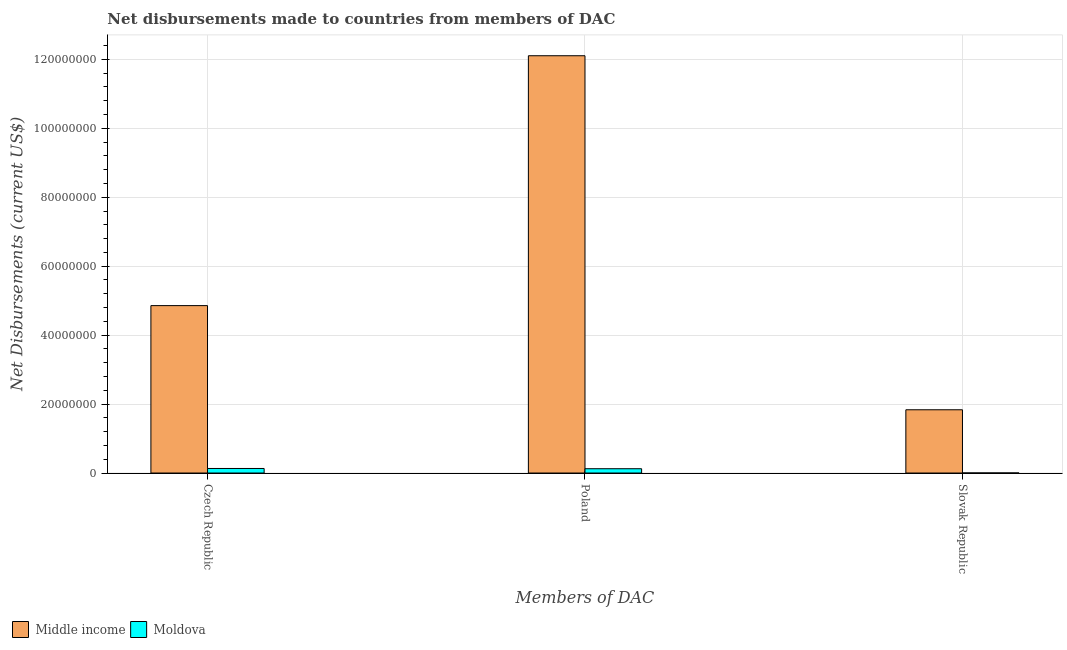How many different coloured bars are there?
Your answer should be compact. 2. How many groups of bars are there?
Your answer should be very brief. 3. Are the number of bars per tick equal to the number of legend labels?
Provide a succinct answer. Yes. Are the number of bars on each tick of the X-axis equal?
Make the answer very short. Yes. How many bars are there on the 1st tick from the left?
Keep it short and to the point. 2. What is the label of the 2nd group of bars from the left?
Offer a very short reply. Poland. What is the net disbursements made by czech republic in Moldova?
Your answer should be very brief. 1.32e+06. Across all countries, what is the maximum net disbursements made by slovak republic?
Your answer should be very brief. 1.84e+07. Across all countries, what is the minimum net disbursements made by poland?
Offer a terse response. 1.25e+06. In which country was the net disbursements made by poland minimum?
Provide a succinct answer. Moldova. What is the total net disbursements made by slovak republic in the graph?
Make the answer very short. 1.84e+07. What is the difference between the net disbursements made by poland in Middle income and that in Moldova?
Provide a short and direct response. 1.20e+08. What is the difference between the net disbursements made by poland in Middle income and the net disbursements made by slovak republic in Moldova?
Your answer should be compact. 1.21e+08. What is the average net disbursements made by poland per country?
Give a very brief answer. 6.11e+07. What is the difference between the net disbursements made by poland and net disbursements made by slovak republic in Moldova?
Keep it short and to the point. 1.23e+06. In how many countries, is the net disbursements made by poland greater than 76000000 US$?
Your response must be concise. 1. What is the ratio of the net disbursements made by poland in Moldova to that in Middle income?
Provide a succinct answer. 0.01. Is the net disbursements made by poland in Moldova less than that in Middle income?
Give a very brief answer. Yes. What is the difference between the highest and the second highest net disbursements made by poland?
Your answer should be very brief. 1.20e+08. What is the difference between the highest and the lowest net disbursements made by poland?
Provide a short and direct response. 1.20e+08. What does the 2nd bar from the left in Czech Republic represents?
Keep it short and to the point. Moldova. How many bars are there?
Keep it short and to the point. 6. What is the difference between two consecutive major ticks on the Y-axis?
Your answer should be compact. 2.00e+07. Are the values on the major ticks of Y-axis written in scientific E-notation?
Your answer should be compact. No. Does the graph contain any zero values?
Offer a terse response. No. Does the graph contain grids?
Your answer should be very brief. Yes. Where does the legend appear in the graph?
Ensure brevity in your answer.  Bottom left. What is the title of the graph?
Your answer should be very brief. Net disbursements made to countries from members of DAC. What is the label or title of the X-axis?
Your response must be concise. Members of DAC. What is the label or title of the Y-axis?
Your response must be concise. Net Disbursements (current US$). What is the Net Disbursements (current US$) in Middle income in Czech Republic?
Give a very brief answer. 4.86e+07. What is the Net Disbursements (current US$) in Moldova in Czech Republic?
Offer a terse response. 1.32e+06. What is the Net Disbursements (current US$) of Middle income in Poland?
Make the answer very short. 1.21e+08. What is the Net Disbursements (current US$) in Moldova in Poland?
Provide a succinct answer. 1.25e+06. What is the Net Disbursements (current US$) of Middle income in Slovak Republic?
Make the answer very short. 1.84e+07. What is the Net Disbursements (current US$) of Moldova in Slovak Republic?
Provide a short and direct response. 2.00e+04. Across all Members of DAC, what is the maximum Net Disbursements (current US$) of Middle income?
Give a very brief answer. 1.21e+08. Across all Members of DAC, what is the maximum Net Disbursements (current US$) in Moldova?
Ensure brevity in your answer.  1.32e+06. Across all Members of DAC, what is the minimum Net Disbursements (current US$) in Middle income?
Offer a very short reply. 1.84e+07. Across all Members of DAC, what is the minimum Net Disbursements (current US$) in Moldova?
Provide a short and direct response. 2.00e+04. What is the total Net Disbursements (current US$) in Middle income in the graph?
Provide a short and direct response. 1.88e+08. What is the total Net Disbursements (current US$) of Moldova in the graph?
Your answer should be compact. 2.59e+06. What is the difference between the Net Disbursements (current US$) in Middle income in Czech Republic and that in Poland?
Ensure brevity in your answer.  -7.25e+07. What is the difference between the Net Disbursements (current US$) of Moldova in Czech Republic and that in Poland?
Keep it short and to the point. 7.00e+04. What is the difference between the Net Disbursements (current US$) in Middle income in Czech Republic and that in Slovak Republic?
Ensure brevity in your answer.  3.02e+07. What is the difference between the Net Disbursements (current US$) in Moldova in Czech Republic and that in Slovak Republic?
Your answer should be very brief. 1.30e+06. What is the difference between the Net Disbursements (current US$) in Middle income in Poland and that in Slovak Republic?
Your answer should be very brief. 1.03e+08. What is the difference between the Net Disbursements (current US$) in Moldova in Poland and that in Slovak Republic?
Provide a short and direct response. 1.23e+06. What is the difference between the Net Disbursements (current US$) in Middle income in Czech Republic and the Net Disbursements (current US$) in Moldova in Poland?
Your response must be concise. 4.73e+07. What is the difference between the Net Disbursements (current US$) in Middle income in Czech Republic and the Net Disbursements (current US$) in Moldova in Slovak Republic?
Provide a short and direct response. 4.85e+07. What is the difference between the Net Disbursements (current US$) of Middle income in Poland and the Net Disbursements (current US$) of Moldova in Slovak Republic?
Your answer should be compact. 1.21e+08. What is the average Net Disbursements (current US$) in Middle income per Members of DAC?
Keep it short and to the point. 6.26e+07. What is the average Net Disbursements (current US$) of Moldova per Members of DAC?
Keep it short and to the point. 8.63e+05. What is the difference between the Net Disbursements (current US$) in Middle income and Net Disbursements (current US$) in Moldova in Czech Republic?
Provide a short and direct response. 4.72e+07. What is the difference between the Net Disbursements (current US$) in Middle income and Net Disbursements (current US$) in Moldova in Poland?
Ensure brevity in your answer.  1.20e+08. What is the difference between the Net Disbursements (current US$) of Middle income and Net Disbursements (current US$) of Moldova in Slovak Republic?
Your answer should be compact. 1.83e+07. What is the ratio of the Net Disbursements (current US$) in Middle income in Czech Republic to that in Poland?
Make the answer very short. 0.4. What is the ratio of the Net Disbursements (current US$) in Moldova in Czech Republic to that in Poland?
Make the answer very short. 1.06. What is the ratio of the Net Disbursements (current US$) of Middle income in Czech Republic to that in Slovak Republic?
Provide a short and direct response. 2.65. What is the ratio of the Net Disbursements (current US$) of Middle income in Poland to that in Slovak Republic?
Your answer should be compact. 6.6. What is the ratio of the Net Disbursements (current US$) in Moldova in Poland to that in Slovak Republic?
Offer a terse response. 62.5. What is the difference between the highest and the second highest Net Disbursements (current US$) of Middle income?
Give a very brief answer. 7.25e+07. What is the difference between the highest and the lowest Net Disbursements (current US$) in Middle income?
Provide a short and direct response. 1.03e+08. What is the difference between the highest and the lowest Net Disbursements (current US$) of Moldova?
Your answer should be very brief. 1.30e+06. 